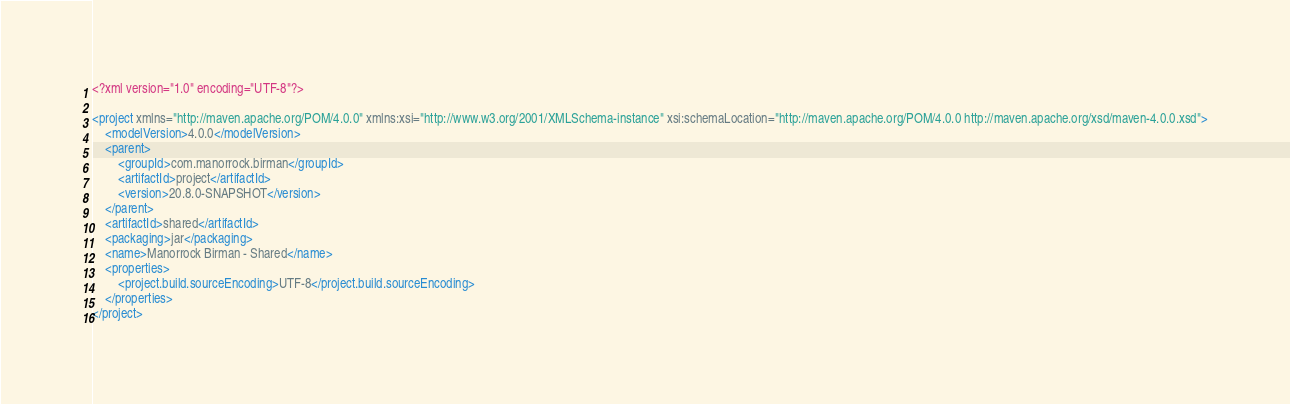<code> <loc_0><loc_0><loc_500><loc_500><_XML_><?xml version="1.0" encoding="UTF-8"?>

<project xmlns="http://maven.apache.org/POM/4.0.0" xmlns:xsi="http://www.w3.org/2001/XMLSchema-instance" xsi:schemaLocation="http://maven.apache.org/POM/4.0.0 http://maven.apache.org/xsd/maven-4.0.0.xsd">
    <modelVersion>4.0.0</modelVersion>
    <parent>
        <groupId>com.manorrock.birman</groupId>
        <artifactId>project</artifactId>
        <version>20.8.0-SNAPSHOT</version>
    </parent>
    <artifactId>shared</artifactId>
    <packaging>jar</packaging>
    <name>Manorrock Birman - Shared</name>
    <properties>
        <project.build.sourceEncoding>UTF-8</project.build.sourceEncoding>
    </properties>
</project></code> 